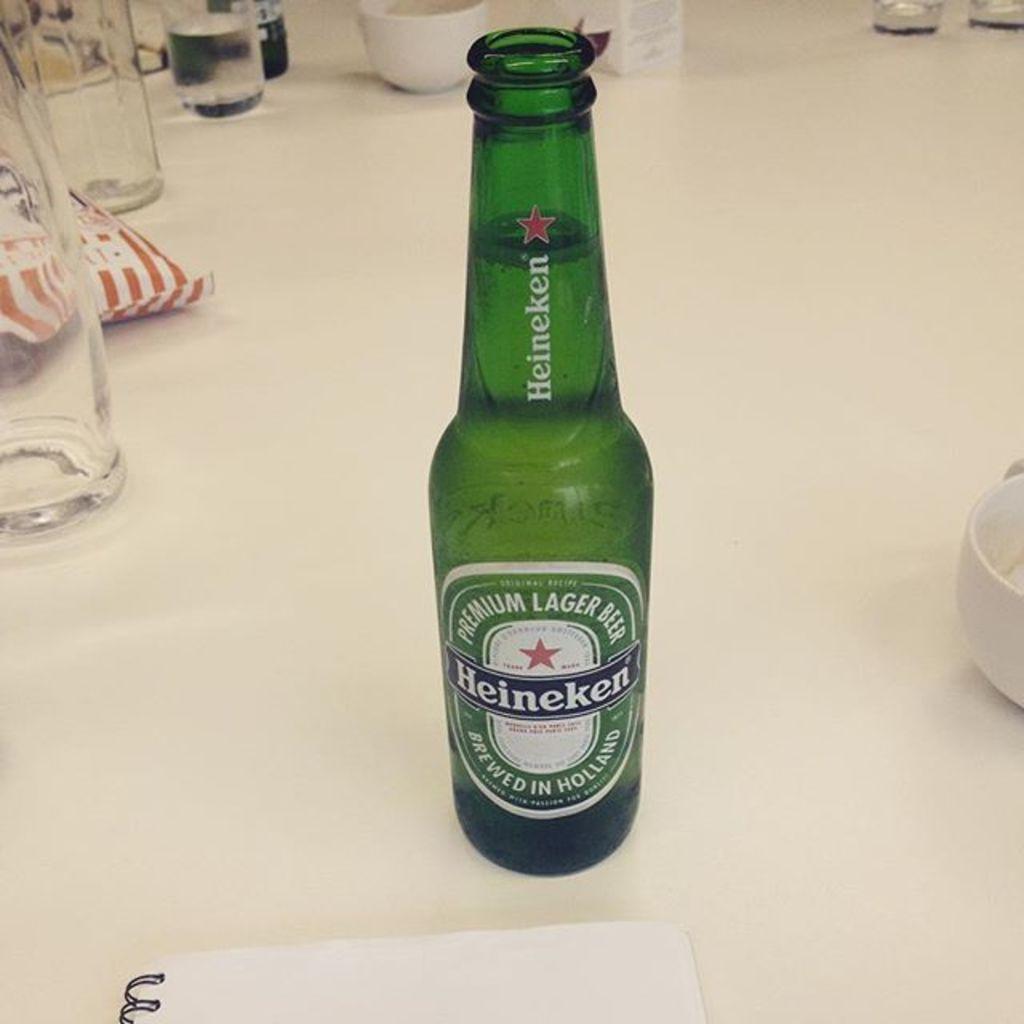How would you summarize this image in a sentence or two? In front of the picture, we see green color glass bottle which is placed on table, on bottle we can see a sticker on with some text is written and on the table, we can see white paper, cup, glass, cover and cool drink bottle. 